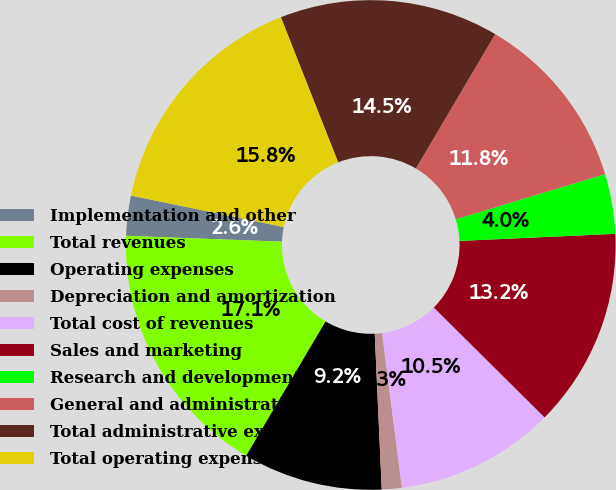Convert chart. <chart><loc_0><loc_0><loc_500><loc_500><pie_chart><fcel>Implementation and other<fcel>Total revenues<fcel>Operating expenses<fcel>Depreciation and amortization<fcel>Total cost of revenues<fcel>Sales and marketing<fcel>Research and development<fcel>General and administrative<fcel>Total administrative expenses<fcel>Total operating expenses<nl><fcel>2.64%<fcel>17.1%<fcel>9.21%<fcel>1.32%<fcel>10.53%<fcel>13.16%<fcel>3.95%<fcel>11.84%<fcel>14.47%<fcel>15.78%<nl></chart> 